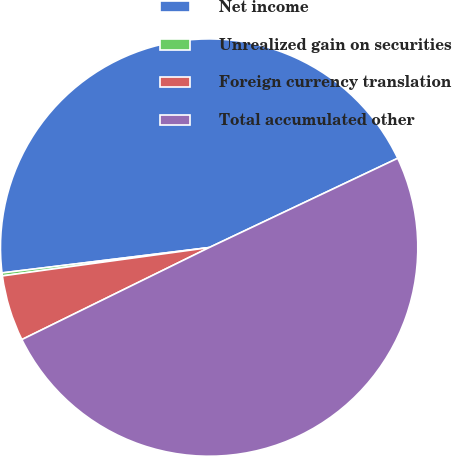<chart> <loc_0><loc_0><loc_500><loc_500><pie_chart><fcel>Net income<fcel>Unrealized gain on securities<fcel>Foreign currency translation<fcel>Total accumulated other<nl><fcel>44.9%<fcel>0.23%<fcel>5.1%<fcel>49.77%<nl></chart> 